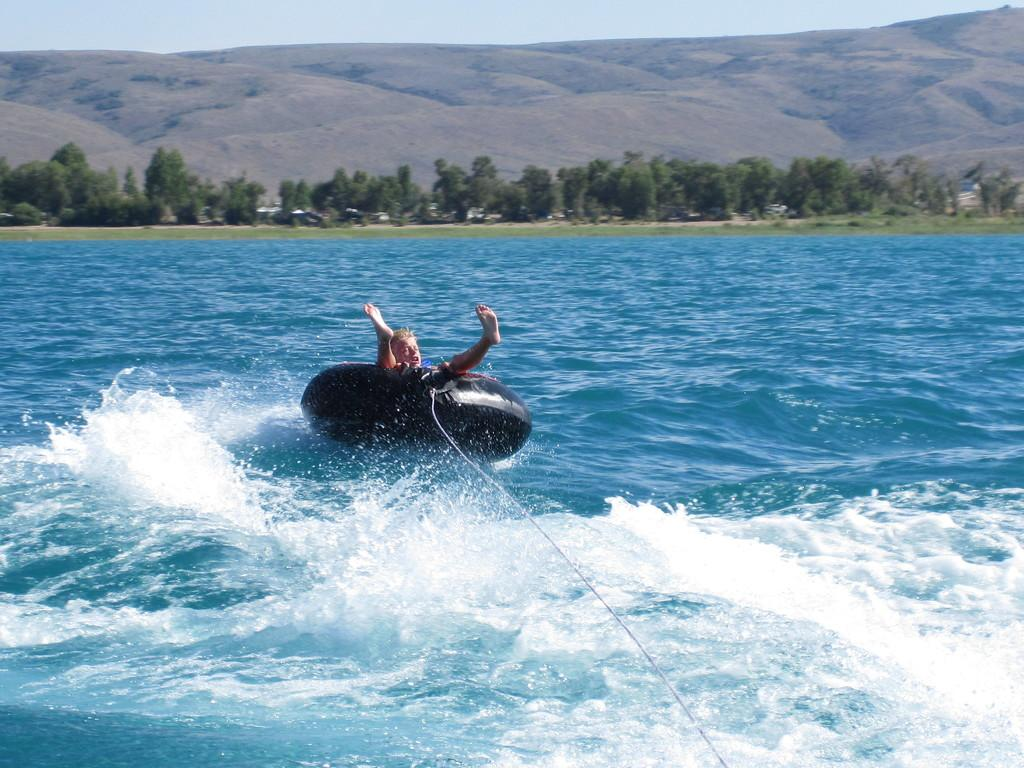Who is the main subject in the image? There is a boy in the image. What is the boy doing in the image? The boy is sitting in a swim tube. Is there anything attached to the swim tube? Yes, there is a rope attached to the swim tube. What can be seen in the background of the image? There are trees and a mountain in the background of the image. What is the condition of the sky in the image? The sky is clear in the image. How many bushes are visible in the image? There are no bushes mentioned or visible in the image. What is the boy's level of wealth based on the image? The image does not provide any information about the boy's wealth. 